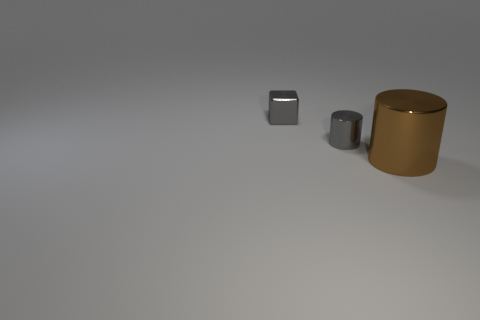Subtract 1 blocks. How many blocks are left? 0 Add 2 large gray rubber cubes. How many objects exist? 5 Subtract all cylinders. How many objects are left? 1 Subtract all yellow cylinders. Subtract all purple balls. How many cylinders are left? 2 Subtract all tiny things. Subtract all brown cylinders. How many objects are left? 0 Add 2 metallic cylinders. How many metallic cylinders are left? 4 Add 2 large brown cylinders. How many large brown cylinders exist? 3 Subtract 0 red cylinders. How many objects are left? 3 